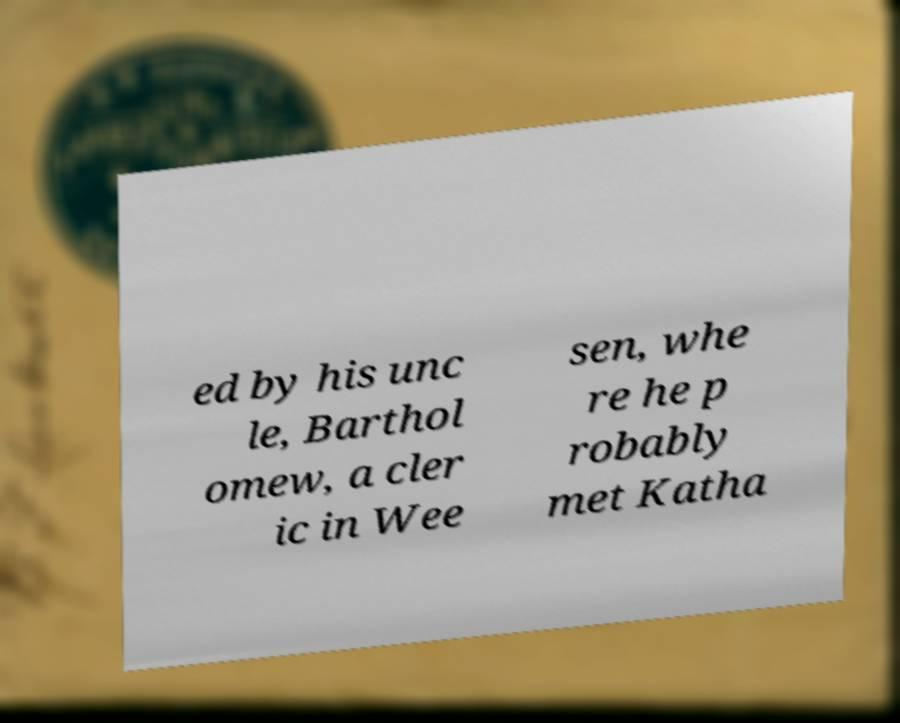Can you accurately transcribe the text from the provided image for me? ed by his unc le, Barthol omew, a cler ic in Wee sen, whe re he p robably met Katha 